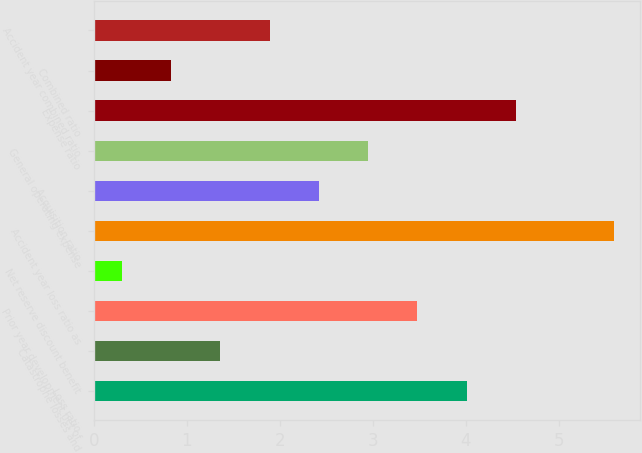Convert chart. <chart><loc_0><loc_0><loc_500><loc_500><bar_chart><fcel>Loss ratio<fcel>Catastrophe losses and<fcel>Prior year development net of<fcel>Net reserve discount benefit<fcel>Accident year loss ratio as<fcel>Acquisition ratio<fcel>General operating expense<fcel>Expense ratio<fcel>Combined ratio<fcel>Accident year combined ratio<nl><fcel>4.01<fcel>1.36<fcel>3.48<fcel>0.3<fcel>5.6<fcel>2.42<fcel>2.95<fcel>4.54<fcel>0.83<fcel>1.89<nl></chart> 